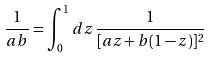<formula> <loc_0><loc_0><loc_500><loc_500>\frac { 1 } { a b } = \int _ { 0 } ^ { 1 } d z \, \frac { 1 } { [ a z + b ( 1 - z ) ] ^ { 2 } }</formula> 